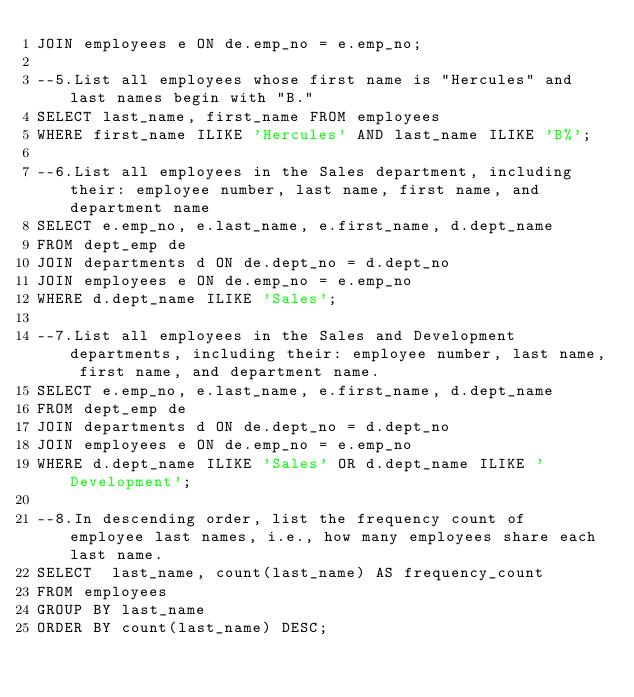Convert code to text. <code><loc_0><loc_0><loc_500><loc_500><_SQL_>JOIN employees e ON de.emp_no = e.emp_no;

--5.List all employees whose first name is "Hercules" and last names begin with "B."
SELECT last_name, first_name FROM employees
WHERE first_name ILIKE 'Hercules' AND last_name ILIKE 'B%';

--6.List all employees in the Sales department, including their: employee number, last name, first name, and department name
SELECT e.emp_no, e.last_name, e.first_name, d.dept_name
FROM dept_emp de
JOIN departments d ON de.dept_no = d.dept_no
JOIN employees e ON de.emp_no = e.emp_no
WHERE d.dept_name ILIKE 'Sales';

--7.List all employees in the Sales and Development departments, including their: employee number, last name, first name, and department name.
SELECT e.emp_no, e.last_name, e.first_name, d.dept_name
FROM dept_emp de
JOIN departments d ON de.dept_no = d.dept_no
JOIN employees e ON de.emp_no = e.emp_no
WHERE d.dept_name ILIKE 'Sales' OR d.dept_name ILIKE 'Development';

--8.In descending order, list the frequency count of employee last names, i.e., how many employees share each last name.
SELECT  last_name, count(last_name) AS frequency_count
FROM employees
GROUP BY last_name
ORDER BY count(last_name) DESC;</code> 